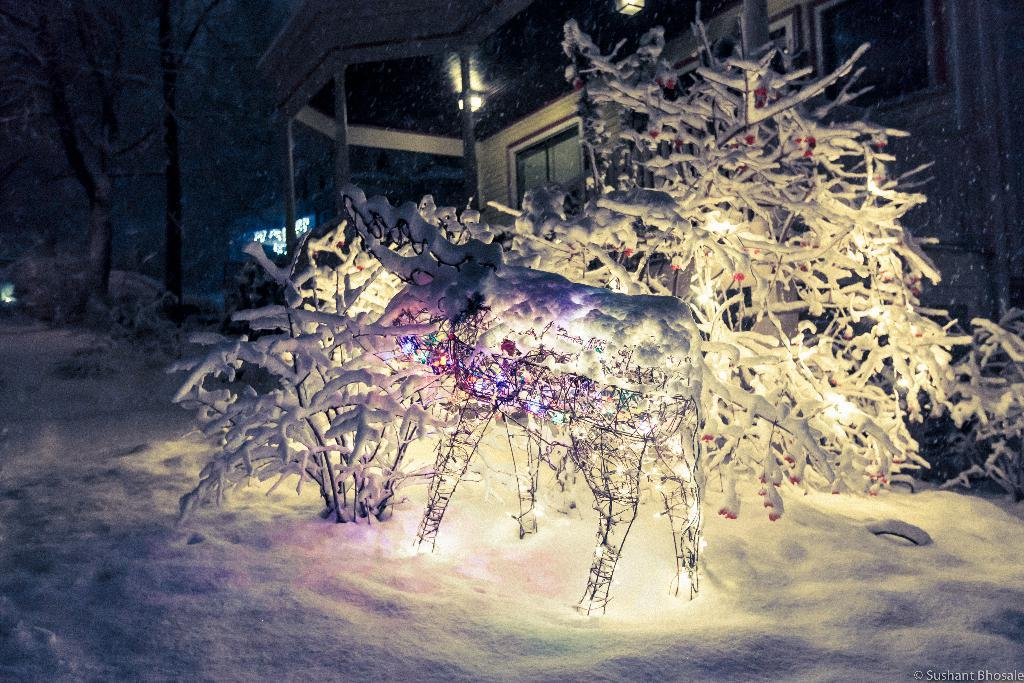What type of natural element is present in the image? There is a tree in the image. What type of man-made structure is present in the image? There is an animal structure in the image. What is the terrain like in the image? The tree and animal structure are on snow. What can be seen in the background of the image? There is a house in the background of the image. What features does the house have? The house has a window, a light, and a pillar. What direction is the field facing in the image? There is no field present in the image. What hobbies does the animal structure enjoy in the image? The animal structure is an inanimate object and does not have hobbies. 